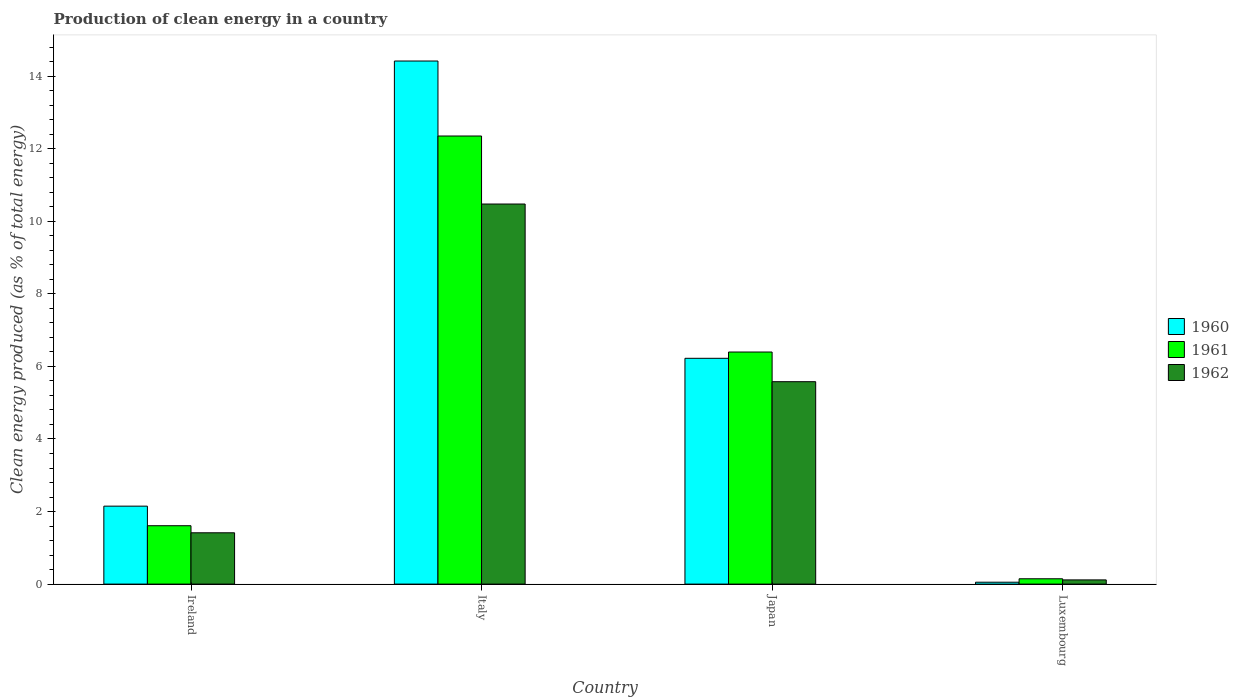How many different coloured bars are there?
Make the answer very short. 3. Are the number of bars on each tick of the X-axis equal?
Offer a terse response. Yes. How many bars are there on the 4th tick from the right?
Offer a very short reply. 3. What is the label of the 4th group of bars from the left?
Give a very brief answer. Luxembourg. In how many cases, is the number of bars for a given country not equal to the number of legend labels?
Offer a very short reply. 0. What is the percentage of clean energy produced in 1960 in Japan?
Give a very brief answer. 6.22. Across all countries, what is the maximum percentage of clean energy produced in 1962?
Give a very brief answer. 10.48. Across all countries, what is the minimum percentage of clean energy produced in 1960?
Your response must be concise. 0.05. In which country was the percentage of clean energy produced in 1960 maximum?
Your response must be concise. Italy. In which country was the percentage of clean energy produced in 1962 minimum?
Make the answer very short. Luxembourg. What is the total percentage of clean energy produced in 1962 in the graph?
Offer a terse response. 17.59. What is the difference between the percentage of clean energy produced in 1961 in Ireland and that in Japan?
Provide a succinct answer. -4.79. What is the difference between the percentage of clean energy produced in 1960 in Luxembourg and the percentage of clean energy produced in 1961 in Italy?
Provide a short and direct response. -12.3. What is the average percentage of clean energy produced in 1961 per country?
Offer a terse response. 5.13. What is the difference between the percentage of clean energy produced of/in 1960 and percentage of clean energy produced of/in 1962 in Italy?
Provide a short and direct response. 3.94. In how many countries, is the percentage of clean energy produced in 1960 greater than 7.6 %?
Your response must be concise. 1. What is the ratio of the percentage of clean energy produced in 1962 in Italy to that in Japan?
Ensure brevity in your answer.  1.88. What is the difference between the highest and the second highest percentage of clean energy produced in 1960?
Offer a very short reply. -12.27. What is the difference between the highest and the lowest percentage of clean energy produced in 1962?
Make the answer very short. 10.36. What does the 3rd bar from the left in Italy represents?
Offer a very short reply. 1962. What does the 3rd bar from the right in Ireland represents?
Your answer should be very brief. 1960. Is it the case that in every country, the sum of the percentage of clean energy produced in 1960 and percentage of clean energy produced in 1962 is greater than the percentage of clean energy produced in 1961?
Offer a terse response. Yes. Are the values on the major ticks of Y-axis written in scientific E-notation?
Keep it short and to the point. No. Does the graph contain grids?
Offer a very short reply. No. How many legend labels are there?
Offer a very short reply. 3. How are the legend labels stacked?
Make the answer very short. Vertical. What is the title of the graph?
Ensure brevity in your answer.  Production of clean energy in a country. What is the label or title of the Y-axis?
Your response must be concise. Clean energy produced (as % of total energy). What is the Clean energy produced (as % of total energy) of 1960 in Ireland?
Provide a succinct answer. 2.15. What is the Clean energy produced (as % of total energy) in 1961 in Ireland?
Your answer should be compact. 1.61. What is the Clean energy produced (as % of total energy) in 1962 in Ireland?
Keep it short and to the point. 1.41. What is the Clean energy produced (as % of total energy) of 1960 in Italy?
Make the answer very short. 14.42. What is the Clean energy produced (as % of total energy) of 1961 in Italy?
Offer a terse response. 12.35. What is the Clean energy produced (as % of total energy) of 1962 in Italy?
Provide a short and direct response. 10.48. What is the Clean energy produced (as % of total energy) of 1960 in Japan?
Ensure brevity in your answer.  6.22. What is the Clean energy produced (as % of total energy) in 1961 in Japan?
Ensure brevity in your answer.  6.4. What is the Clean energy produced (as % of total energy) in 1962 in Japan?
Offer a very short reply. 5.58. What is the Clean energy produced (as % of total energy) of 1960 in Luxembourg?
Offer a terse response. 0.05. What is the Clean energy produced (as % of total energy) of 1961 in Luxembourg?
Provide a short and direct response. 0.15. What is the Clean energy produced (as % of total energy) of 1962 in Luxembourg?
Keep it short and to the point. 0.12. Across all countries, what is the maximum Clean energy produced (as % of total energy) of 1960?
Your response must be concise. 14.42. Across all countries, what is the maximum Clean energy produced (as % of total energy) in 1961?
Your answer should be very brief. 12.35. Across all countries, what is the maximum Clean energy produced (as % of total energy) of 1962?
Your answer should be compact. 10.48. Across all countries, what is the minimum Clean energy produced (as % of total energy) of 1960?
Keep it short and to the point. 0.05. Across all countries, what is the minimum Clean energy produced (as % of total energy) in 1961?
Give a very brief answer. 0.15. Across all countries, what is the minimum Clean energy produced (as % of total energy) in 1962?
Ensure brevity in your answer.  0.12. What is the total Clean energy produced (as % of total energy) in 1960 in the graph?
Your response must be concise. 22.84. What is the total Clean energy produced (as % of total energy) of 1961 in the graph?
Give a very brief answer. 20.5. What is the total Clean energy produced (as % of total energy) of 1962 in the graph?
Keep it short and to the point. 17.59. What is the difference between the Clean energy produced (as % of total energy) of 1960 in Ireland and that in Italy?
Give a very brief answer. -12.27. What is the difference between the Clean energy produced (as % of total energy) of 1961 in Ireland and that in Italy?
Provide a short and direct response. -10.74. What is the difference between the Clean energy produced (as % of total energy) of 1962 in Ireland and that in Italy?
Ensure brevity in your answer.  -9.06. What is the difference between the Clean energy produced (as % of total energy) in 1960 in Ireland and that in Japan?
Give a very brief answer. -4.08. What is the difference between the Clean energy produced (as % of total energy) of 1961 in Ireland and that in Japan?
Your response must be concise. -4.79. What is the difference between the Clean energy produced (as % of total energy) of 1962 in Ireland and that in Japan?
Your response must be concise. -4.16. What is the difference between the Clean energy produced (as % of total energy) in 1960 in Ireland and that in Luxembourg?
Your answer should be very brief. 2.1. What is the difference between the Clean energy produced (as % of total energy) of 1961 in Ireland and that in Luxembourg?
Ensure brevity in your answer.  1.46. What is the difference between the Clean energy produced (as % of total energy) of 1962 in Ireland and that in Luxembourg?
Keep it short and to the point. 1.3. What is the difference between the Clean energy produced (as % of total energy) of 1960 in Italy and that in Japan?
Ensure brevity in your answer.  8.19. What is the difference between the Clean energy produced (as % of total energy) of 1961 in Italy and that in Japan?
Your answer should be very brief. 5.95. What is the difference between the Clean energy produced (as % of total energy) of 1962 in Italy and that in Japan?
Your answer should be compact. 4.9. What is the difference between the Clean energy produced (as % of total energy) in 1960 in Italy and that in Luxembourg?
Offer a very short reply. 14.37. What is the difference between the Clean energy produced (as % of total energy) in 1961 in Italy and that in Luxembourg?
Give a very brief answer. 12.2. What is the difference between the Clean energy produced (as % of total energy) in 1962 in Italy and that in Luxembourg?
Offer a terse response. 10.36. What is the difference between the Clean energy produced (as % of total energy) of 1960 in Japan and that in Luxembourg?
Your answer should be compact. 6.17. What is the difference between the Clean energy produced (as % of total energy) of 1961 in Japan and that in Luxembourg?
Offer a very short reply. 6.25. What is the difference between the Clean energy produced (as % of total energy) in 1962 in Japan and that in Luxembourg?
Your answer should be very brief. 5.46. What is the difference between the Clean energy produced (as % of total energy) of 1960 in Ireland and the Clean energy produced (as % of total energy) of 1961 in Italy?
Ensure brevity in your answer.  -10.2. What is the difference between the Clean energy produced (as % of total energy) in 1960 in Ireland and the Clean energy produced (as % of total energy) in 1962 in Italy?
Provide a short and direct response. -8.33. What is the difference between the Clean energy produced (as % of total energy) in 1961 in Ireland and the Clean energy produced (as % of total energy) in 1962 in Italy?
Your answer should be very brief. -8.87. What is the difference between the Clean energy produced (as % of total energy) of 1960 in Ireland and the Clean energy produced (as % of total energy) of 1961 in Japan?
Provide a short and direct response. -4.25. What is the difference between the Clean energy produced (as % of total energy) of 1960 in Ireland and the Clean energy produced (as % of total energy) of 1962 in Japan?
Your answer should be very brief. -3.43. What is the difference between the Clean energy produced (as % of total energy) of 1961 in Ireland and the Clean energy produced (as % of total energy) of 1962 in Japan?
Offer a terse response. -3.97. What is the difference between the Clean energy produced (as % of total energy) of 1960 in Ireland and the Clean energy produced (as % of total energy) of 1961 in Luxembourg?
Make the answer very short. 2. What is the difference between the Clean energy produced (as % of total energy) of 1960 in Ireland and the Clean energy produced (as % of total energy) of 1962 in Luxembourg?
Provide a short and direct response. 2.03. What is the difference between the Clean energy produced (as % of total energy) in 1961 in Ireland and the Clean energy produced (as % of total energy) in 1962 in Luxembourg?
Give a very brief answer. 1.49. What is the difference between the Clean energy produced (as % of total energy) of 1960 in Italy and the Clean energy produced (as % of total energy) of 1961 in Japan?
Offer a very short reply. 8.02. What is the difference between the Clean energy produced (as % of total energy) of 1960 in Italy and the Clean energy produced (as % of total energy) of 1962 in Japan?
Provide a short and direct response. 8.84. What is the difference between the Clean energy produced (as % of total energy) in 1961 in Italy and the Clean energy produced (as % of total energy) in 1962 in Japan?
Give a very brief answer. 6.77. What is the difference between the Clean energy produced (as % of total energy) of 1960 in Italy and the Clean energy produced (as % of total energy) of 1961 in Luxembourg?
Ensure brevity in your answer.  14.27. What is the difference between the Clean energy produced (as % of total energy) in 1960 in Italy and the Clean energy produced (as % of total energy) in 1962 in Luxembourg?
Provide a succinct answer. 14.3. What is the difference between the Clean energy produced (as % of total energy) in 1961 in Italy and the Clean energy produced (as % of total energy) in 1962 in Luxembourg?
Your answer should be compact. 12.23. What is the difference between the Clean energy produced (as % of total energy) of 1960 in Japan and the Clean energy produced (as % of total energy) of 1961 in Luxembourg?
Make the answer very short. 6.08. What is the difference between the Clean energy produced (as % of total energy) in 1960 in Japan and the Clean energy produced (as % of total energy) in 1962 in Luxembourg?
Ensure brevity in your answer.  6.11. What is the difference between the Clean energy produced (as % of total energy) in 1961 in Japan and the Clean energy produced (as % of total energy) in 1962 in Luxembourg?
Ensure brevity in your answer.  6.28. What is the average Clean energy produced (as % of total energy) of 1960 per country?
Keep it short and to the point. 5.71. What is the average Clean energy produced (as % of total energy) in 1961 per country?
Keep it short and to the point. 5.13. What is the average Clean energy produced (as % of total energy) of 1962 per country?
Provide a succinct answer. 4.4. What is the difference between the Clean energy produced (as % of total energy) in 1960 and Clean energy produced (as % of total energy) in 1961 in Ireland?
Ensure brevity in your answer.  0.54. What is the difference between the Clean energy produced (as % of total energy) of 1960 and Clean energy produced (as % of total energy) of 1962 in Ireland?
Your answer should be compact. 0.73. What is the difference between the Clean energy produced (as % of total energy) of 1961 and Clean energy produced (as % of total energy) of 1962 in Ireland?
Your answer should be compact. 0.19. What is the difference between the Clean energy produced (as % of total energy) of 1960 and Clean energy produced (as % of total energy) of 1961 in Italy?
Offer a terse response. 2.07. What is the difference between the Clean energy produced (as % of total energy) in 1960 and Clean energy produced (as % of total energy) in 1962 in Italy?
Your response must be concise. 3.94. What is the difference between the Clean energy produced (as % of total energy) of 1961 and Clean energy produced (as % of total energy) of 1962 in Italy?
Give a very brief answer. 1.87. What is the difference between the Clean energy produced (as % of total energy) in 1960 and Clean energy produced (as % of total energy) in 1961 in Japan?
Ensure brevity in your answer.  -0.17. What is the difference between the Clean energy produced (as % of total energy) of 1960 and Clean energy produced (as % of total energy) of 1962 in Japan?
Your response must be concise. 0.64. What is the difference between the Clean energy produced (as % of total energy) of 1961 and Clean energy produced (as % of total energy) of 1962 in Japan?
Offer a very short reply. 0.82. What is the difference between the Clean energy produced (as % of total energy) of 1960 and Clean energy produced (as % of total energy) of 1961 in Luxembourg?
Ensure brevity in your answer.  -0.09. What is the difference between the Clean energy produced (as % of total energy) of 1960 and Clean energy produced (as % of total energy) of 1962 in Luxembourg?
Provide a succinct answer. -0.06. What is the difference between the Clean energy produced (as % of total energy) in 1961 and Clean energy produced (as % of total energy) in 1962 in Luxembourg?
Keep it short and to the point. 0.03. What is the ratio of the Clean energy produced (as % of total energy) in 1960 in Ireland to that in Italy?
Your answer should be compact. 0.15. What is the ratio of the Clean energy produced (as % of total energy) in 1961 in Ireland to that in Italy?
Ensure brevity in your answer.  0.13. What is the ratio of the Clean energy produced (as % of total energy) of 1962 in Ireland to that in Italy?
Your answer should be very brief. 0.14. What is the ratio of the Clean energy produced (as % of total energy) in 1960 in Ireland to that in Japan?
Provide a succinct answer. 0.35. What is the ratio of the Clean energy produced (as % of total energy) of 1961 in Ireland to that in Japan?
Provide a short and direct response. 0.25. What is the ratio of the Clean energy produced (as % of total energy) in 1962 in Ireland to that in Japan?
Keep it short and to the point. 0.25. What is the ratio of the Clean energy produced (as % of total energy) of 1960 in Ireland to that in Luxembourg?
Offer a very short reply. 41.27. What is the ratio of the Clean energy produced (as % of total energy) in 1961 in Ireland to that in Luxembourg?
Make the answer very short. 10.96. What is the ratio of the Clean energy produced (as % of total energy) of 1962 in Ireland to that in Luxembourg?
Give a very brief answer. 12.21. What is the ratio of the Clean energy produced (as % of total energy) of 1960 in Italy to that in Japan?
Your response must be concise. 2.32. What is the ratio of the Clean energy produced (as % of total energy) of 1961 in Italy to that in Japan?
Your response must be concise. 1.93. What is the ratio of the Clean energy produced (as % of total energy) of 1962 in Italy to that in Japan?
Make the answer very short. 1.88. What is the ratio of the Clean energy produced (as % of total energy) in 1960 in Italy to that in Luxembourg?
Provide a short and direct response. 276.95. What is the ratio of the Clean energy produced (as % of total energy) in 1961 in Italy to that in Luxembourg?
Your answer should be compact. 84.09. What is the ratio of the Clean energy produced (as % of total energy) in 1962 in Italy to that in Luxembourg?
Your response must be concise. 90.43. What is the ratio of the Clean energy produced (as % of total energy) of 1960 in Japan to that in Luxembourg?
Offer a terse response. 119.55. What is the ratio of the Clean energy produced (as % of total energy) of 1961 in Japan to that in Luxembourg?
Provide a succinct answer. 43.55. What is the ratio of the Clean energy produced (as % of total energy) in 1962 in Japan to that in Luxembourg?
Your answer should be very brief. 48.16. What is the difference between the highest and the second highest Clean energy produced (as % of total energy) of 1960?
Give a very brief answer. 8.19. What is the difference between the highest and the second highest Clean energy produced (as % of total energy) of 1961?
Your answer should be very brief. 5.95. What is the difference between the highest and the second highest Clean energy produced (as % of total energy) of 1962?
Provide a short and direct response. 4.9. What is the difference between the highest and the lowest Clean energy produced (as % of total energy) of 1960?
Provide a succinct answer. 14.37. What is the difference between the highest and the lowest Clean energy produced (as % of total energy) of 1961?
Give a very brief answer. 12.2. What is the difference between the highest and the lowest Clean energy produced (as % of total energy) in 1962?
Offer a terse response. 10.36. 